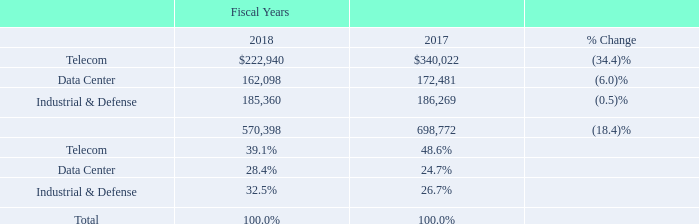Comparison of Fiscal Year Ended September 28, 2018 to Fiscal Year Ended September 29, 2017
We acquired AppliedMicro on January 26, 2017 and certain assets of Picometrix on August 9, 2017, and we divested the Compute business on October 27, 2017 and our LR4 business on May 10, 2018. For additional information related to acquisitions and divestitures refer to Note 4 - Acquisitions and Note 23 - Divested Business and Discontinued Operations, respectively, in this Annual Report.
Our annual Statements of Operations includes activity since the dates of acquisition for AppliedMicro and Picometrix and excludes activity for the Compute business and LR4 business after the date of the divestiture, representing less than twelve months of activity for AppliedMicro and Picometrix for the fiscal year ended September 29, 2017.
Revenue. In fiscal year 2018, our revenue decreased by $128.4 million, or 18.4%, to $570.4 million from $698.8 million for fiscal year 2017. Revenue from our primary markets, the percentage of change between the years and revenue by primary markets expressed as a percentage of total revenue were (in thousands, except percentages):
In fiscal year 2018, our Telecom market revenue decreased by $117.1 million, or 34.4%, compared to fiscal year 2017. The decrease was primarily due to lower sales of carrier-based optical semiconductor products to our Asia customer base, lower sales of products targeting fiber to the home applications and the May 2018 sale of our LR4 business.
In fiscal year 2018, our Data Center market revenue decreased by $10.4 million, or 6.0%, compared to fiscal year 2017. The decrease was primarily due to decreased revenue from sales of legacy optical products and lasers and cloud data center applications.
In fiscal year 2018, our I&D market revenues decreased by $0.9 million, or 0.5%, compared to fiscal year 2017. The decrease was primarily related to lower certain legacy defense products partially offset by higher revenue across other areas within the product portfolio.
What led to decrease in I&D market revenues? Lower certain legacy defense products partially offset by higher revenue across other areas within the product portfolio. What is the change in Telecom value between fiscal year 2017 and 2018?
Answer scale should be: thousand. 222,940-340,022
Answer: -117082. What is the average Telecom value for fiscal year 2017 and 2018?
Answer scale should be: thousand. (222,940+340,022) / 2
Answer: 281481. In which year was Telecom value less than 300,000 thousand? Locate and analyze telecom in row 3
answer: 2018. What was the respective value of Data Center in 2019 and 2018?
Answer scale should be: thousand. 162,098, 172,481. When was AppliedMicro acquired? January 26, 2017. 